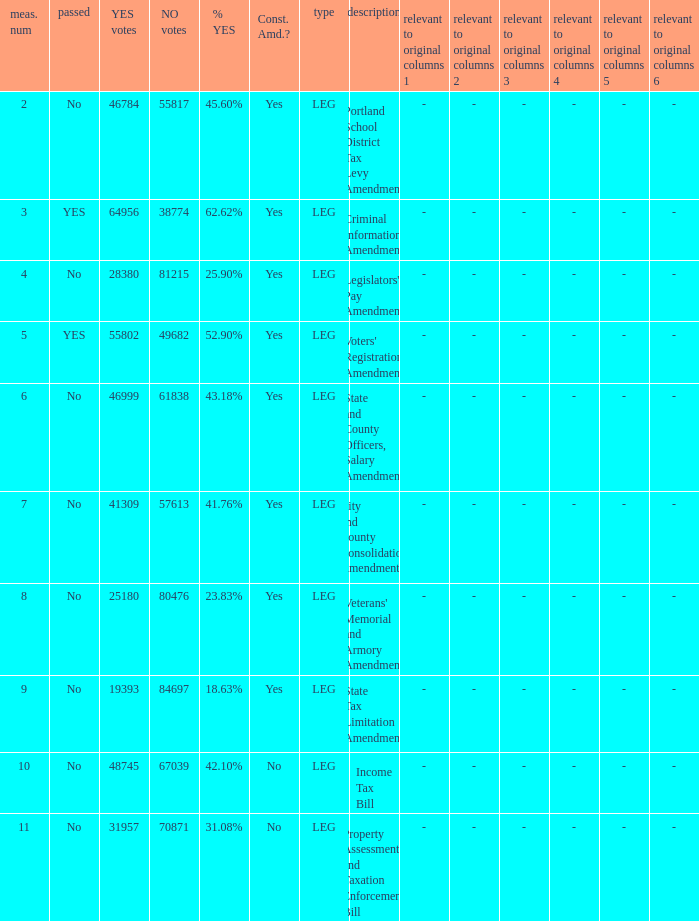HOw many no votes were there when there were 45.60% yes votes 55817.0. 